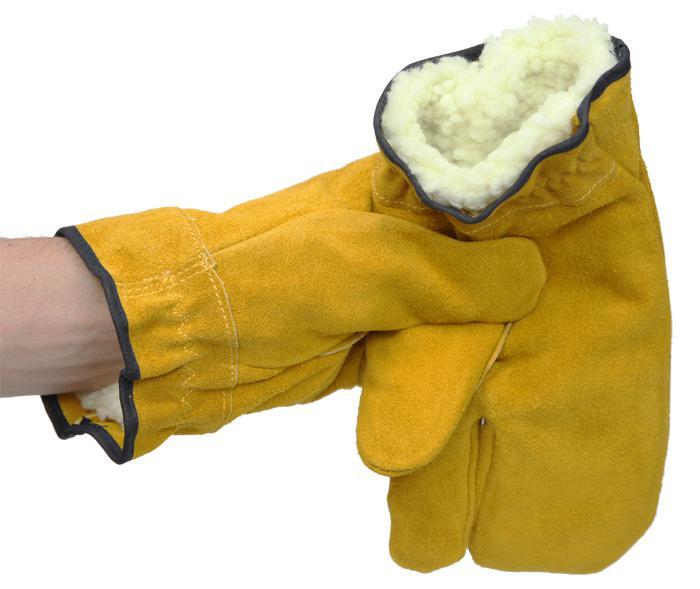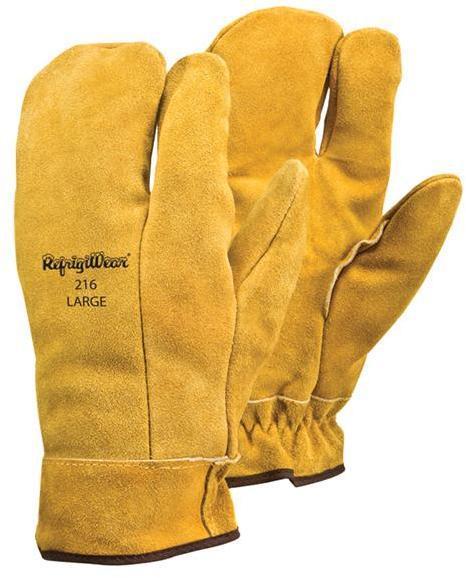The first image is the image on the left, the second image is the image on the right. Assess this claim about the two images: "In one image a pair of yellow-gold gloves are shown, the back view of one and the front view of the other, while the second image shows at least one similar glove with a human arm extended.". Correct or not? Answer yes or no. Yes. The first image is the image on the left, the second image is the image on the right. Analyze the images presented: Is the assertion "Someone is wearing one of the gloves." valid? Answer yes or no. Yes. 